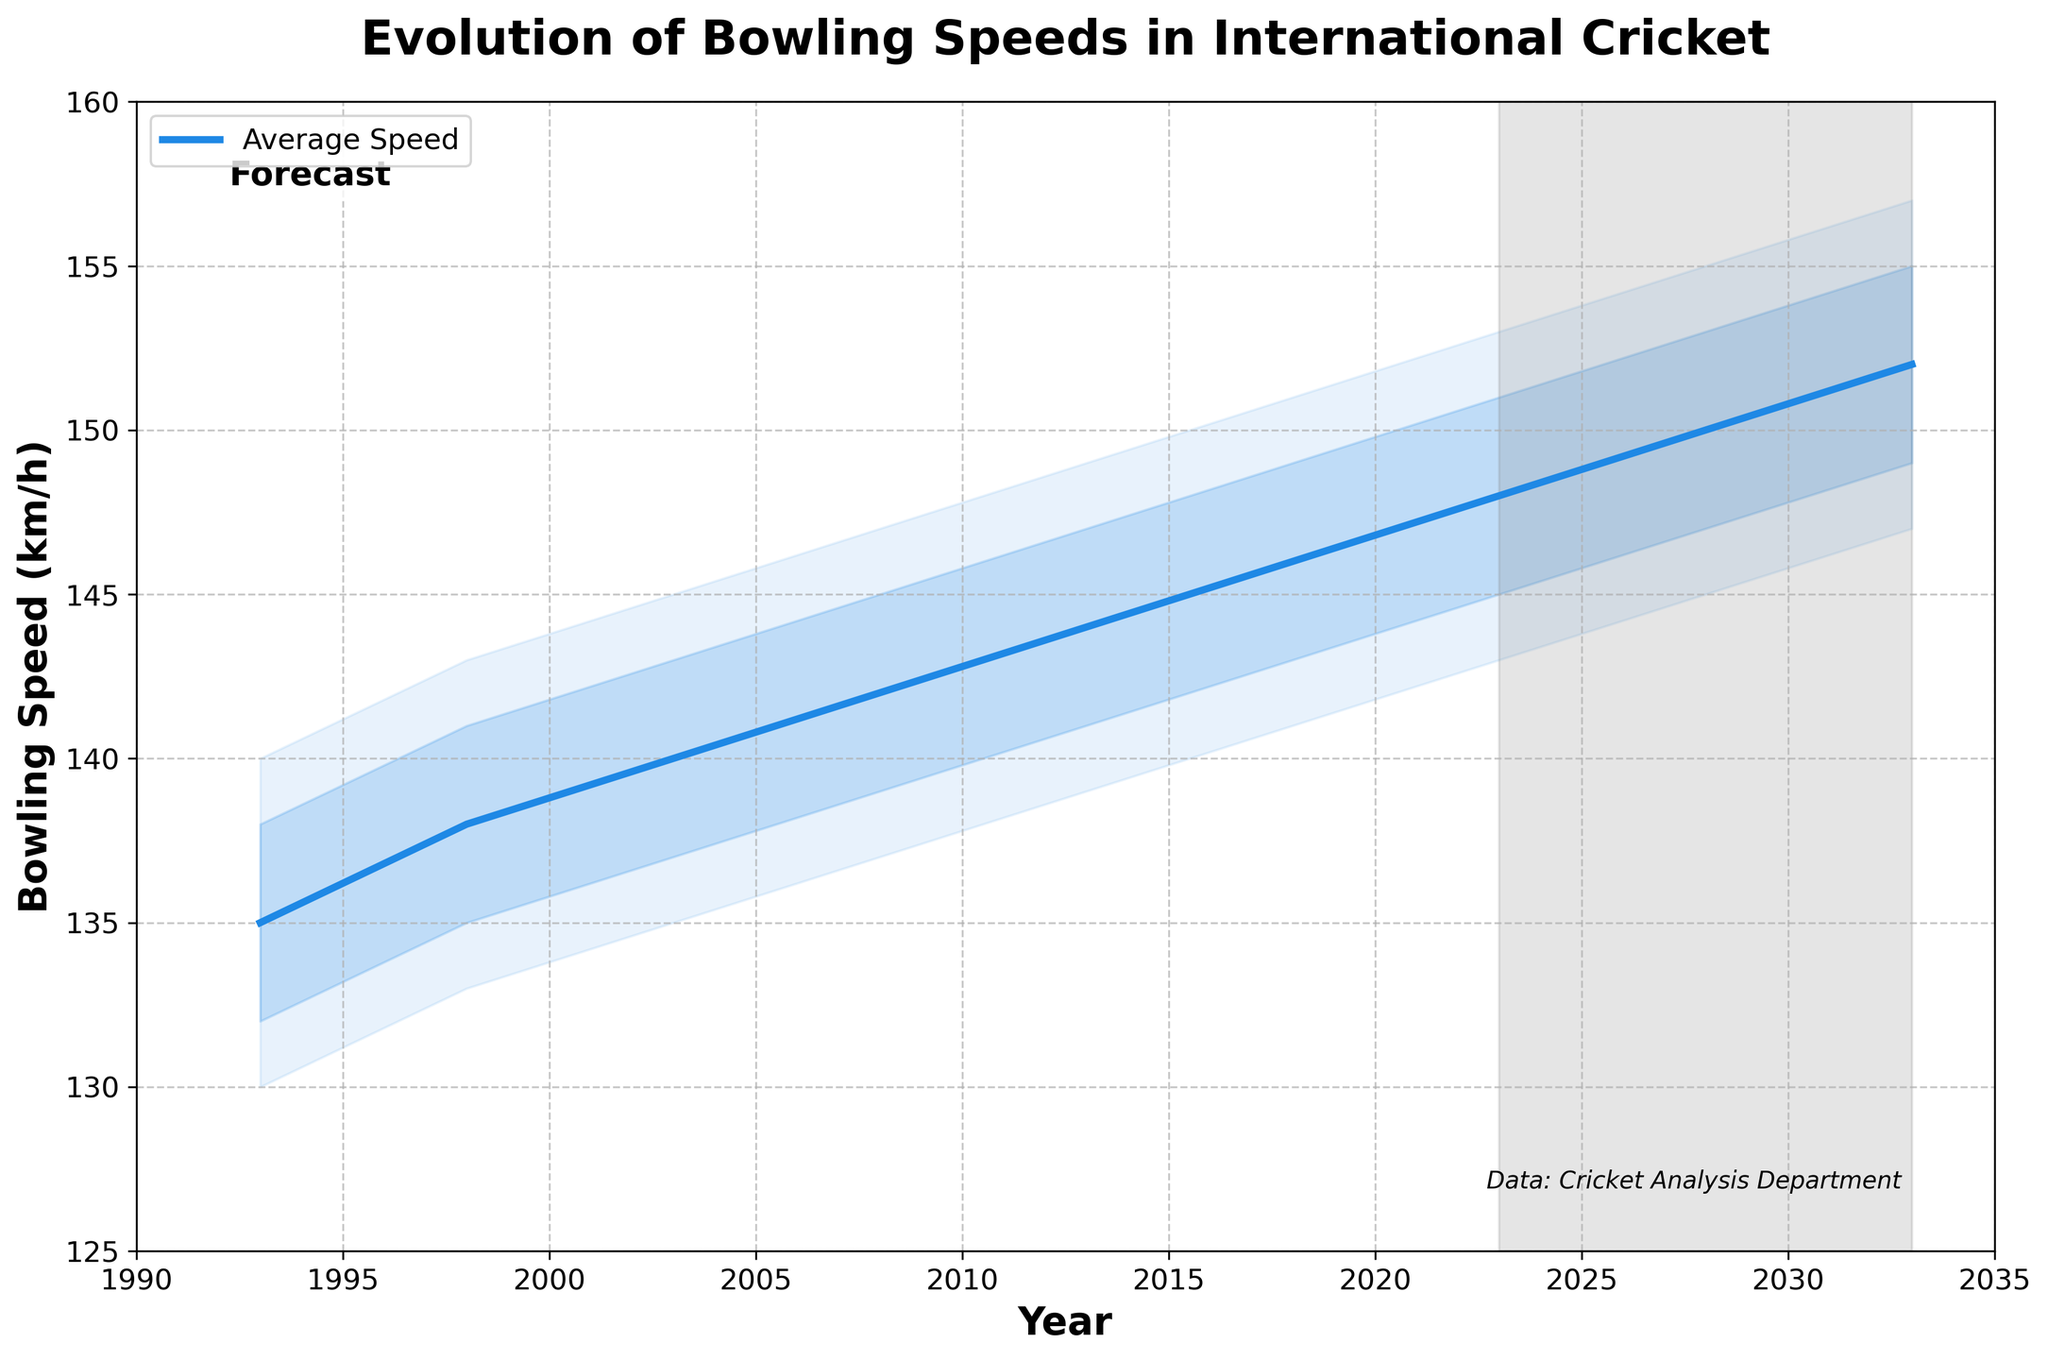What is the title of the chart? The title of the chart is located prominently at the top and reads, "Evolution of Bowling Speeds in International Cricket."
Answer: Evolution of Bowling Speeds in International Cricket What does the shaded area between 2023 and 2033 represent? A gray shaded area is marked from 2023 to 2033, indicating that it represents the forecasted trends for the future.
Answer: Forecast What is the average bowling speed in the year 2008? The average speed for any given year can be found by referring to the blue line labeled 'Average Speed.' For 2008, the value is 142 km/h.
Answer: 142 km/h By how much has the average bowling speed increased from 1993 to 2023? The average speed in 1993 is 135 km/h and in 2023 it is 148 km/h. The increase is calculated as 148 - 135 = 13 km/h.
Answer: 13 km/h What are the maximum and minimum values for the upper 90th percentile in the dataset? The maximum and minimum values for the upper 90th percentile can be found by looking at the boundary of the light blue shaded area at its highest points, which are 153 km/h in 2023 and 140 km/h in 1993.
Answer: 153 km/h (max), 140 km/h (min) How does the forecasted increase in average speed from 2023 to 2033 compare to the increase from 2003 to 2013? The increase from 2003 to 2013 is 144 - 140 = 4 km/h. The forecasted increase from 2023 to 2033 is 152 - 148 = 4 km/h. Both periods show the same increase in average speed.
Answer: 4 km/h (same) What is the range of bowling speeds for the 75th percentile in 2018? The range can be determined by looking at the upper 75th percentile for 2018. The values are between the lower and upper bounds of the darker blue shaded area, from 143 km/h to 149 km/h.
Answer: 6 km/h Compare the lower 10th percentile speeds of 2013 and 2028. Which is higher? The lower 10th percentile for 2013 is 139 km/h, and for 2028 it is 145 km/h. Comparing these values, 145 km/h is higher.
Answer: 145 km/h Is the increase in the lower 25th percentile speed from 1993 to 2018 greater or less than the increase in the upper 75th percentile speed for the same period? Lower 25th percentile increases from 132 km/h in 1993 to 143 km/h in 2018, a difference of 11 km/h. The upper 75th percentile increases from 138 km/h to 149 km/h, a difference of 11 km/h. Both increases are equal.
Answer: Equal Based on the trends shown in the chart, what is the expected average bowling speed in 2033? By referring to the extended blue line into the forecasted area from 2023 onwards, the expected average bowling speed in 2033 is shown to be 152 km/h.
Answer: 152 km/h 